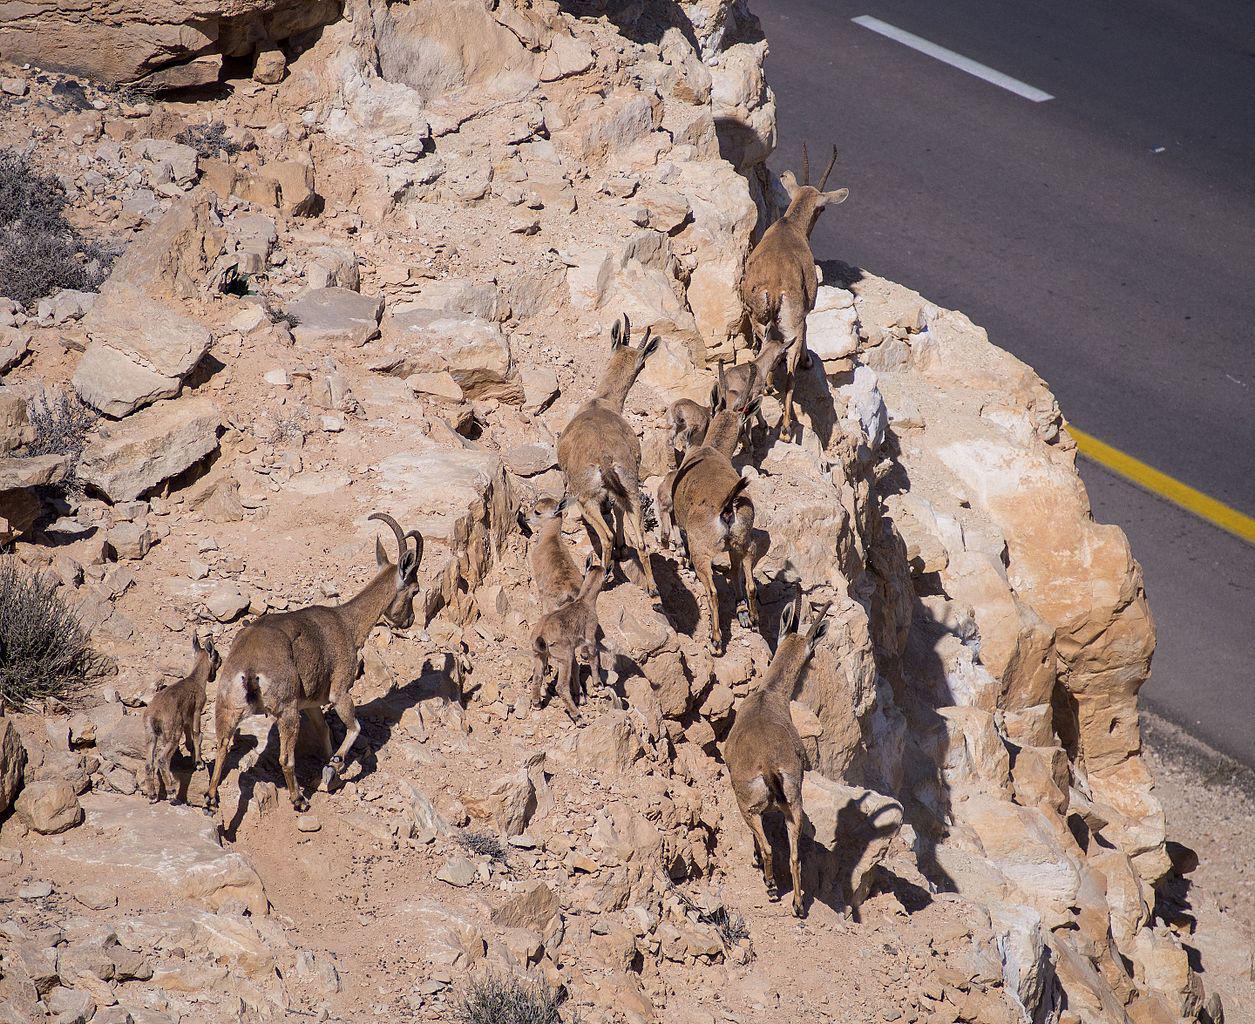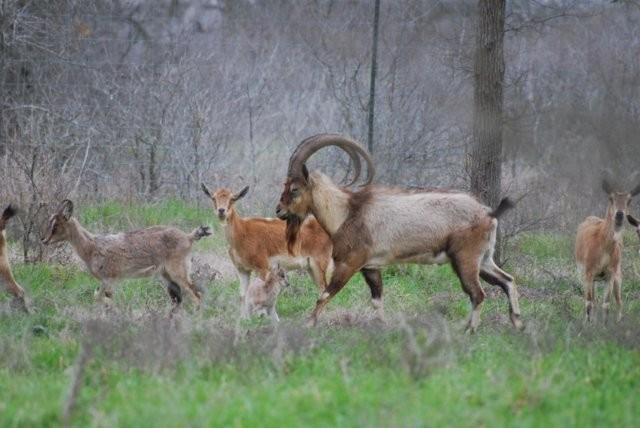The first image is the image on the left, the second image is the image on the right. Analyze the images presented: Is the assertion "At least one of the animals is standing in a grassy area." valid? Answer yes or no. Yes. The first image is the image on the left, the second image is the image on the right. For the images shown, is this caption "An image shows three horned animals on a surface with flat stones arranged in a row." true? Answer yes or no. No. 